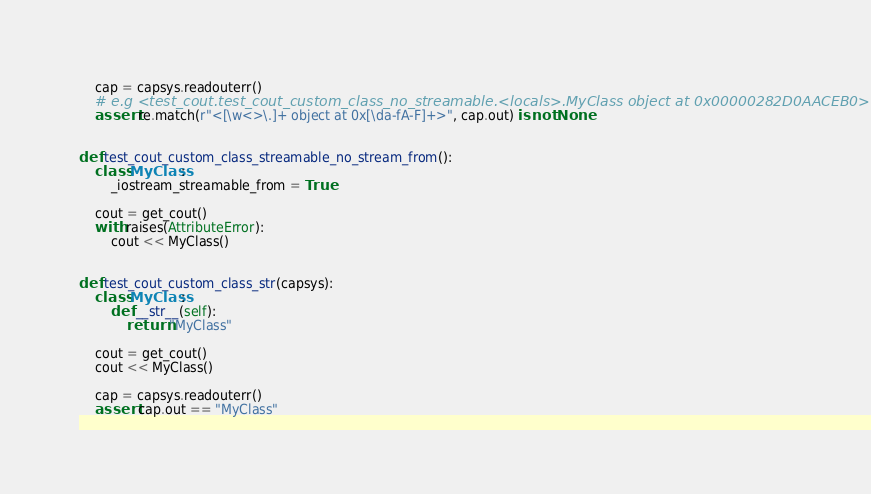Convert code to text. <code><loc_0><loc_0><loc_500><loc_500><_Python_>    cap = capsys.readouterr()
    # e.g <test_cout.test_cout_custom_class_no_streamable.<locals>.MyClass object at 0x00000282D0AACEB0>
    assert re.match(r"<[\w<>\.]+ object at 0x[\da-fA-F]+>", cap.out) is not None


def test_cout_custom_class_streamable_no_stream_from():
    class MyClass:
        _iostream_streamable_from = True

    cout = get_cout()
    with raises(AttributeError):
        cout << MyClass()


def test_cout_custom_class_str(capsys):
    class MyClass:
        def __str__(self):
            return "MyClass"

    cout = get_cout()
    cout << MyClass()

    cap = capsys.readouterr()
    assert cap.out == "MyClass"
</code> 